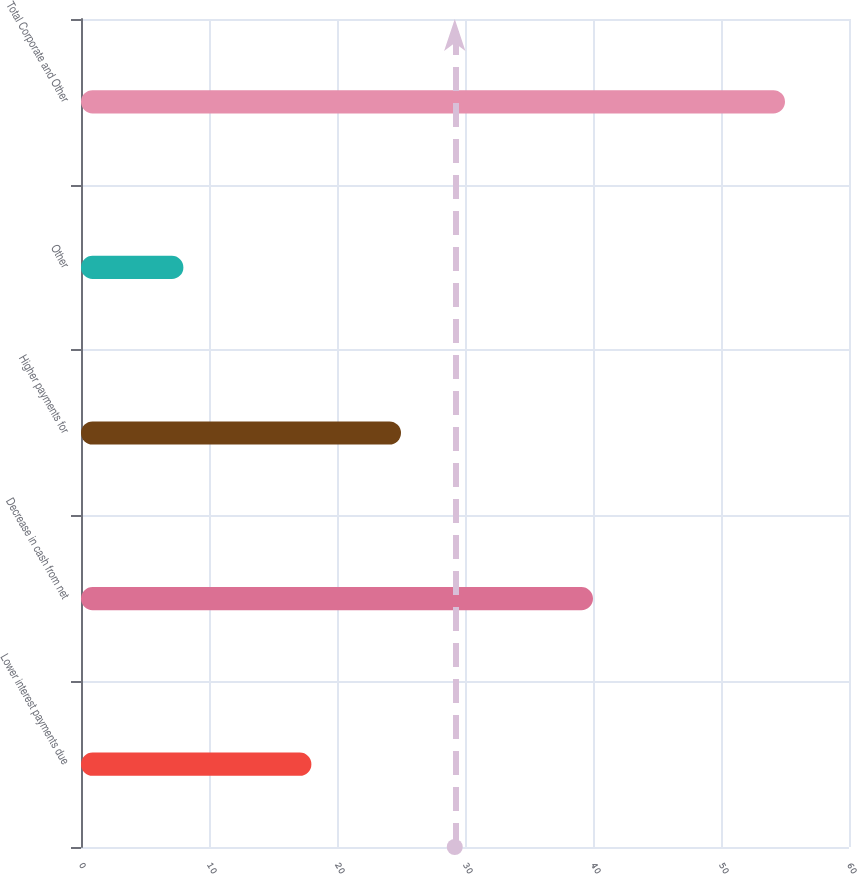Convert chart. <chart><loc_0><loc_0><loc_500><loc_500><bar_chart><fcel>Lower interest payments due<fcel>Decrease in cash from net<fcel>Higher payments for<fcel>Other<fcel>Total Corporate and Other<nl><fcel>18<fcel>40<fcel>25<fcel>8<fcel>55<nl></chart> 